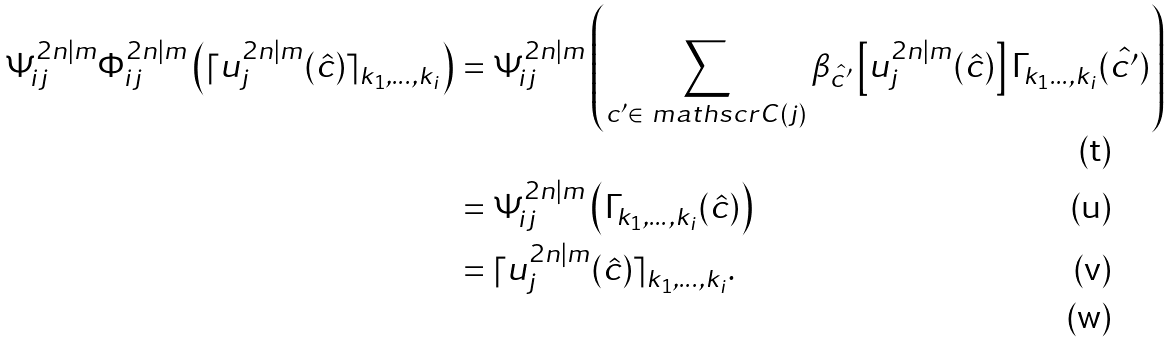<formula> <loc_0><loc_0><loc_500><loc_500>\Psi ^ { 2 n | m } _ { i j } \Phi ^ { 2 n | m } _ { i j } \left ( \lceil u ^ { 2 n | m } _ { j } ( \hat { c } ) \rceil _ { k _ { 1 } , \dots , k _ { i } } \right ) & = \Psi ^ { 2 n | m } _ { i j } \left ( \sum _ { c ^ { \prime } \in \ m a t h s c r { C } ( j ) } \beta _ { \hat { c ^ { \prime } } } \left [ u ^ { 2 n | m } _ { j } ( \hat { c } ) \right ] \Gamma _ { k _ { 1 } \dots , k _ { i } } ( \hat { c ^ { \prime } } ) \right ) \\ & = \Psi ^ { 2 n | m } _ { i j } \left ( \Gamma _ { k _ { 1 } , \dots , k _ { i } } ( \hat { c } ) \right ) \\ & = \lceil u ^ { 2 n | m } _ { j } ( \hat { c } ) \rceil _ { k _ { 1 } , \dots , k _ { i } } . \\</formula> 